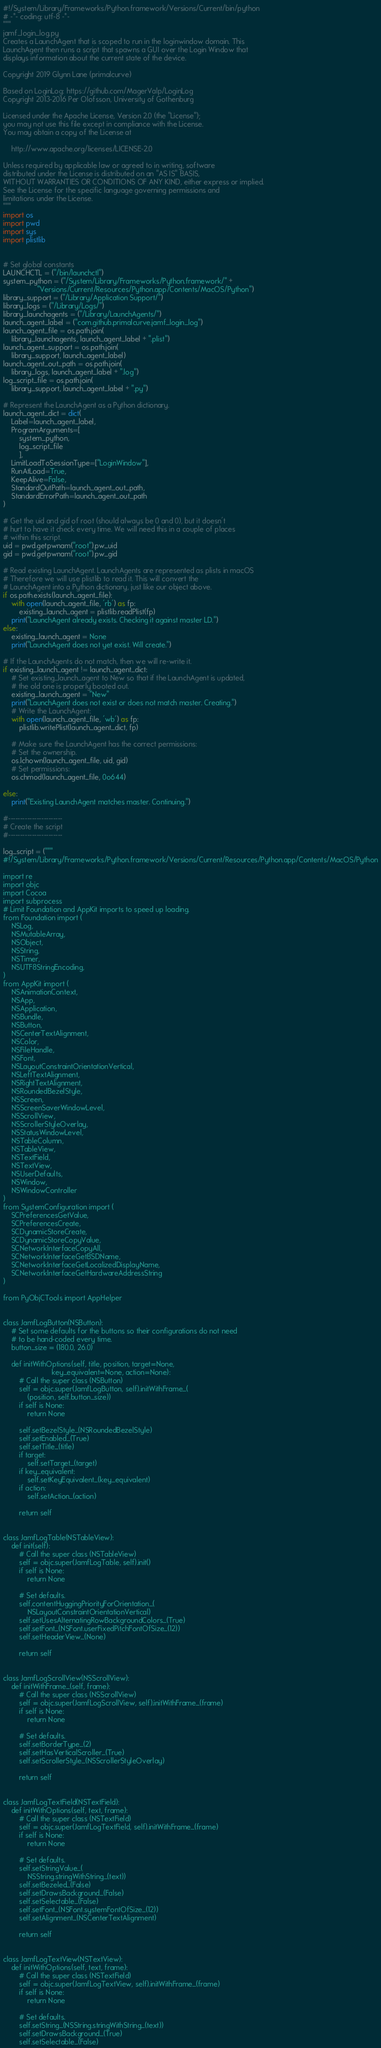Convert code to text. <code><loc_0><loc_0><loc_500><loc_500><_Python_>#!/System/Library/Frameworks/Python.framework/Versions/Current/bin/python
# -*- coding: utf-8 -*-
"""
jamf_login_log.py
Creates a LaunchAgent that is scoped to run in the loginwindow domain. This
LaunchAgent then runs a script that spawns a GUI over the Login Window that
displays information about the current state of the device.

Copyright 2019 Glynn Lane (primalcurve)

Based on LoginLog: https://github.com/MagerValp/LoginLog
Copyright 2013-2016 Per Olofsson, University of Gothenburg

Licensed under the Apache License, Version 2.0 (the "License");
you may not use this file except in compliance with the License.
You may obtain a copy of the License at

    http://www.apache.org/licenses/LICENSE-2.0

Unless required by applicable law or agreed to in writing, software
distributed under the License is distributed on an "AS IS" BASIS,
WITHOUT WARRANTIES OR CONDITIONS OF ANY KIND, either express or implied.
See the License for the specific language governing permissions and
limitations under the License.
"""
import os
import pwd
import sys
import plistlib


# Set global constants
LAUNCHCTL = ("/bin/launchctl")
system_python = ("/System/Library/Frameworks/Python.framework/" +
                 "Versions/Current/Resources/Python.app/Contents/MacOS/Python")
library_support = ("/Library/Application Support/")
library_logs = ("/Library/Logs/")
library_launchagents = ("/Library/LaunchAgents/")
launch_agent_label = ("com.github.primalcurve.jamf_login_log")
launch_agent_file = os.path.join(
    library_launchagents, launch_agent_label + ".plist")
launch_agent_support = os.path.join(
    library_support, launch_agent_label)
launch_agent_out_path = os.path.join(
    library_logs, launch_agent_label + ".log")
log_script_file = os.path.join(
    library_support, launch_agent_label + ".py")

# Represent the LaunchAgent as a Python dictionary.
launch_agent_dict = dict(
    Label=launch_agent_label,
    ProgramArguments=[
        system_python,
        log_script_file
        ],
    LimitLoadToSessionType=["LoginWindow"],
    RunAtLoad=True,
    KeepAlive=False,
    StandardOutPath=launch_agent_out_path,
    StandardErrorPath=launch_agent_out_path
)

# Get the uid and gid of root (should always be 0 and 0), but it doesn't
# hurt to have it check every time. We will need this in a couple of places
# within this script.
uid = pwd.getpwnam("root").pw_uid
gid = pwd.getpwnam("root").pw_gid

# Read existing LaunchAgent. LaunchAgents are represented as plists in macOS
# Therefore we will use plistlib to read it. This will convert the
# LaunchAgent into a Python dictionary, just like our object above.
if os.path.exists(launch_agent_file):
    with open(launch_agent_file, 'rb') as fp:
        existing_launch_agent = plistlib.readPlist(fp)
    print("LaunchAgent already exists. Checking it against master LD.")
else:
    existing_launch_agent = None
    print("LaunchAgent does not yet exist. Will create.")

# If the LaunchAgents do not match, then we will re-write it.
if existing_launch_agent != launch_agent_dict:
    # Set existing_launch_agent to New so that if the LaunchAgent is updated,
    # the old one is properly booted out.
    existing_launch_agent = "New"
    print("LaunchAgent does not exist or does not match master. Creating.")
    # Write the LaunchAgent:
    with open(launch_agent_file, 'wb') as fp:
        plistlib.writePlist(launch_agent_dict, fp)

    # Make sure the LaunchAgent has the correct permissions:
    # Set the ownership.
    os.lchown(launch_agent_file, uid, gid)
    # Set permissions:
    os.chmod(launch_agent_file, 0o644)

else:
    print("Existing LaunchAgent matches master. Continuing.")

#-----------------------
# Create the script
#-----------------------

log_script = ("""
#!/System/Library/Frameworks/Python.framework/Versions/Current/Resources/Python.app/Contents/MacOS/Python

import re
import objc
import Cocoa
import subprocess
# Limit Foundation and AppKit imports to speed up loading.
from Foundation import (
    NSLog,
    NSMutableArray,
    NSObject,
    NSString,
    NSTimer,
    NSUTF8StringEncoding,
)
from AppKit import (
    NSAnimationContext,
    NSApp,
    NSApplication,
    NSBundle,
    NSButton,
    NSCenterTextAlignment,
    NSColor,
    NSFileHandle,
    NSFont,
    NSLayoutConstraintOrientationVertical,
    NSLeftTextAlignment,
    NSRightTextAlignment,
    NSRoundedBezelStyle,
    NSScreen,
    NSScreenSaverWindowLevel,
    NSScrollView,
    NSScrollerStyleOverlay,
    NSStatusWindowLevel,
    NSTableColumn,
    NSTableView,
    NSTextField,
    NSTextView,
    NSUserDefaults,
    NSWindow,
    NSWindowController
)
from SystemConfiguration import (
    SCPreferencesGetValue,
    SCPreferencesCreate,
    SCDynamicStoreCreate,
    SCDynamicStoreCopyValue,
    SCNetworkInterfaceCopyAll,
    SCNetworkInterfaceGetBSDName,
    SCNetworkInterfaceGetLocalizedDisplayName,
    SCNetworkInterfaceGetHardwareAddressString
)

from PyObjCTools import AppHelper


class JamfLogButton(NSButton):
    # Set some defaults for the buttons so their configurations do not need
    # to be hand-coded every time.
    button_size = (180.0, 26.0)

    def initWithOptions(self, title, position, target=None,
                        key_equivalent=None, action=None):
        # Call the super class (NSButton)
        self = objc.super(JamfLogButton, self).initWithFrame_(
            (position, self.button_size))
        if self is None:
            return None

        self.setBezelStyle_(NSRoundedBezelStyle)
        self.setEnabled_(True)
        self.setTitle_(title)
        if target:
            self.setTarget_(target)
        if key_equivalent:
            self.setKeyEquivalent_(key_equivalent)
        if action:
            self.setAction_(action)

        return self


class JamfLogTable(NSTableView):
    def init(self):
        # Call the super class (NSTableView)
        self = objc.super(JamfLogTable, self).init()
        if self is None:
            return None

        # Set defaults.
        self.contentHuggingPriorityForOrientation_(
            NSLayoutConstraintOrientationVertical)
        self.setUsesAlternatingRowBackgroundColors_(True)
        self.setFont_(NSFont.userFixedPitchFontOfSize_(12))
        self.setHeaderView_(None)

        return self


class JamfLogScrollView(NSScrollView):
    def initWithFrame_(self, frame):
        # Call the super class (NSScrollView)
        self = objc.super(JamfLogScrollView, self).initWithFrame_(frame)
        if self is None:
            return None

        # Set defaults.
        self.setBorderType_(2)
        self.setHasVerticalScroller_(True)
        self.setScrollerStyle_(NSScrollerStyleOverlay)

        return self


class JamfLogTextField(NSTextField):
    def initWithOptions(self, text, frame):
        # Call the super class (NSTextField)
        self = objc.super(JamfLogTextField, self).initWithFrame_(frame)
        if self is None:
            return None

        # Set defaults.
        self.setStringValue_(
            NSString.stringWithString_(text))
        self.setBezeled_(False)
        self.setDrawsBackground_(False)
        self.setSelectable_(False)
        self.setFont_(NSFont.systemFontOfSize_(12))
        self.setAlignment_(NSCenterTextAlignment)

        return self


class JamfLogTextView(NSTextView):
    def initWithOptions(self, text, frame):
        # Call the super class (NSTextField)
        self = objc.super(JamfLogTextView, self).initWithFrame_(frame)
        if self is None:
            return None

        # Set defaults.
        self.setString_(NSString.stringWithString_(text))
        self.setDrawsBackground_(True)
        self.setSelectable_(False)</code> 